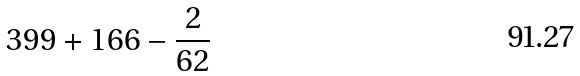<formula> <loc_0><loc_0><loc_500><loc_500>3 9 9 + 1 6 6 - \frac { 2 } { 6 2 }</formula> 